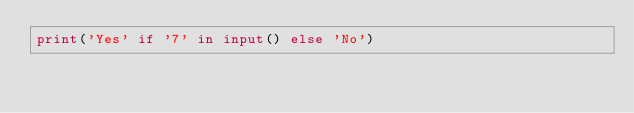Convert code to text. <code><loc_0><loc_0><loc_500><loc_500><_Python_>print('Yes' if '7' in input() else 'No')</code> 